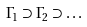Convert formula to latex. <formula><loc_0><loc_0><loc_500><loc_500>\Gamma _ { 1 } \supset \Gamma _ { 2 } \supset \dots</formula> 